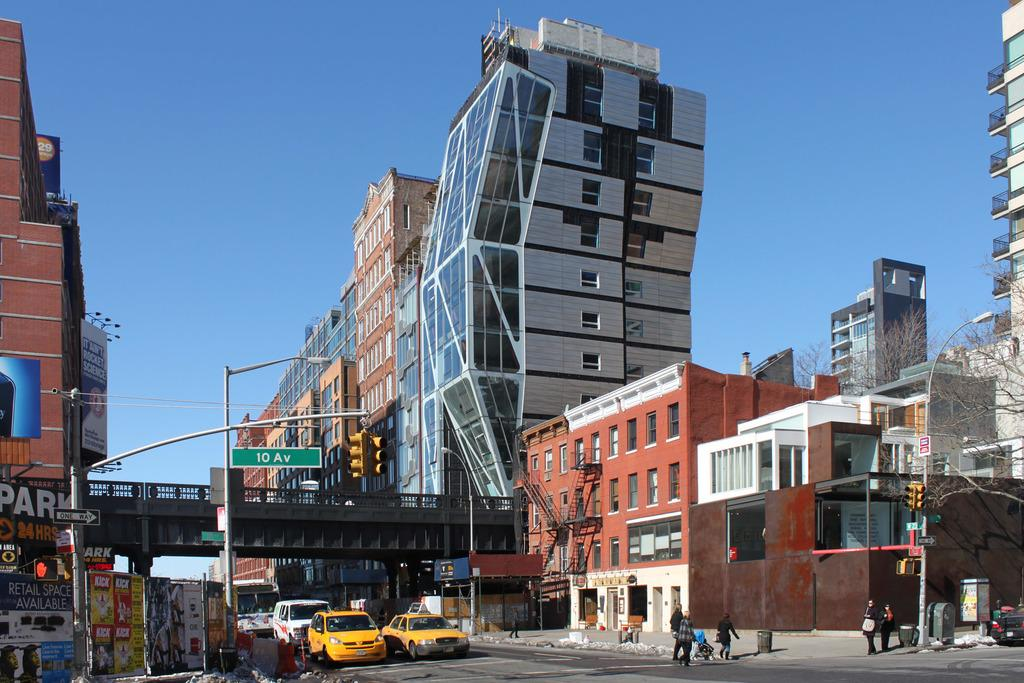<image>
Present a compact description of the photo's key features. 10 av is shown above the city street 